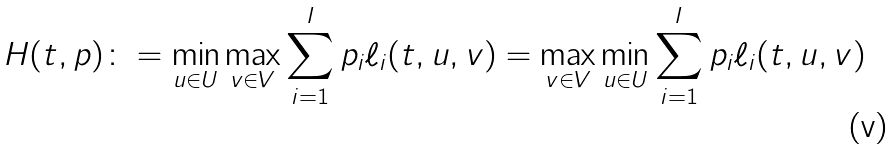<formula> <loc_0><loc_0><loc_500><loc_500>H ( t , p ) \colon = \min _ { u \in U } \max _ { v \in V } \sum _ { i = 1 } ^ { I } p _ { i } \ell _ { i } ( t , u , v ) = \max _ { v \in V } \min _ { u \in U } \sum _ { i = 1 } ^ { I } p _ { i } \ell _ { i } ( t , u , v )</formula> 